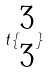Convert formula to latex. <formula><loc_0><loc_0><loc_500><loc_500>t \{ \begin{matrix} 3 \\ 3 \end{matrix} \}</formula> 